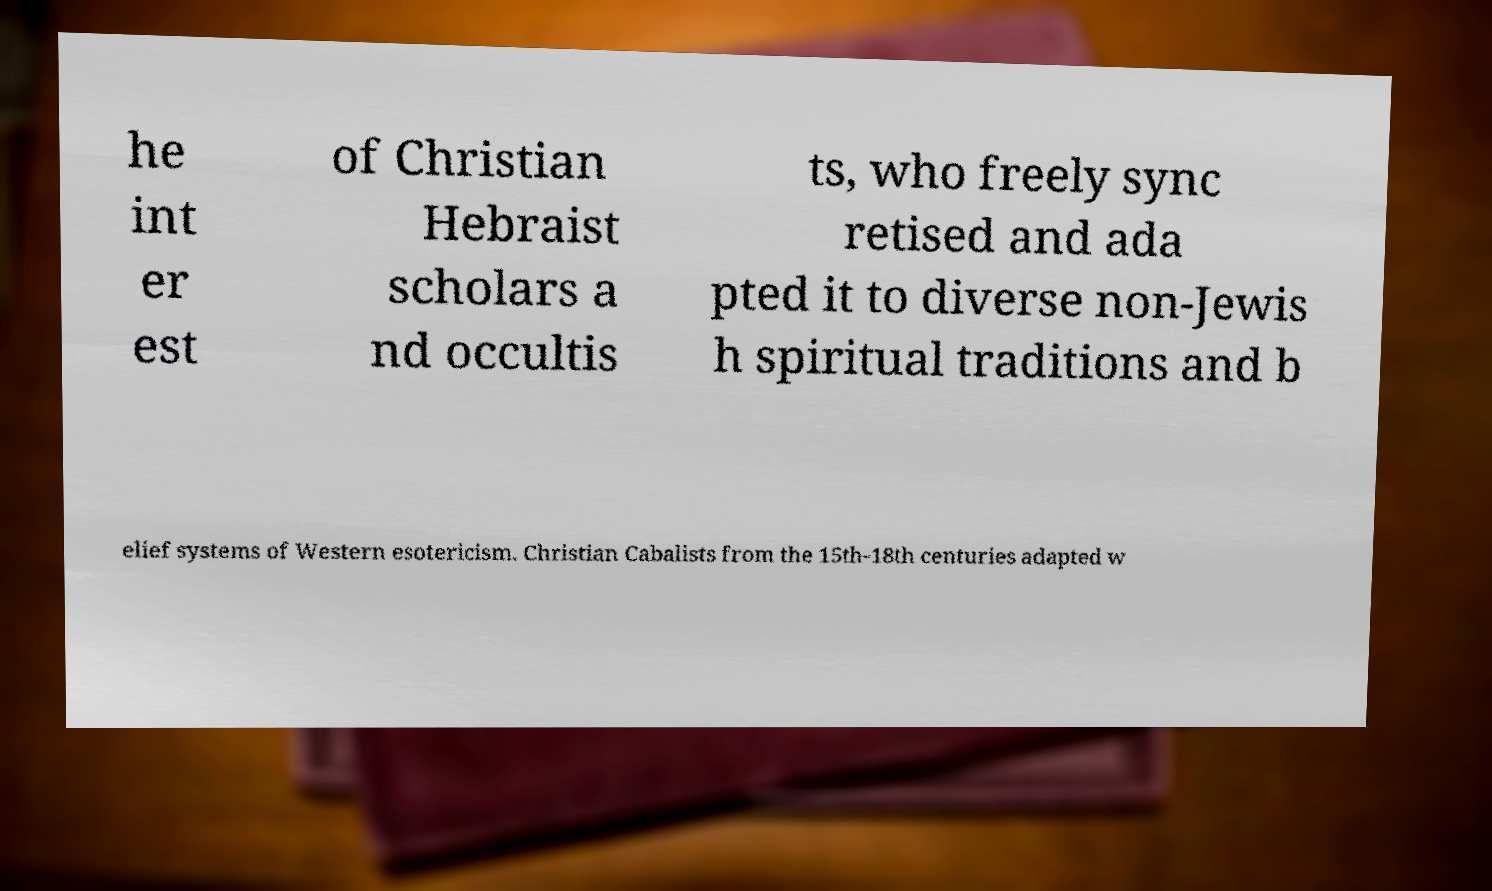Can you accurately transcribe the text from the provided image for me? he int er est of Christian Hebraist scholars a nd occultis ts, who freely sync retised and ada pted it to diverse non-Jewis h spiritual traditions and b elief systems of Western esotericism. Christian Cabalists from the 15th-18th centuries adapted w 